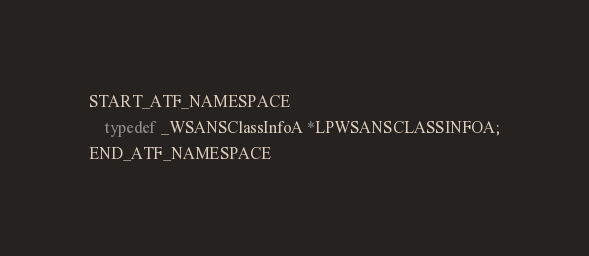<code> <loc_0><loc_0><loc_500><loc_500><_C++_>

START_ATF_NAMESPACE
    typedef _WSANSClassInfoA *LPWSANSCLASSINFOA;
END_ATF_NAMESPACE
</code> 